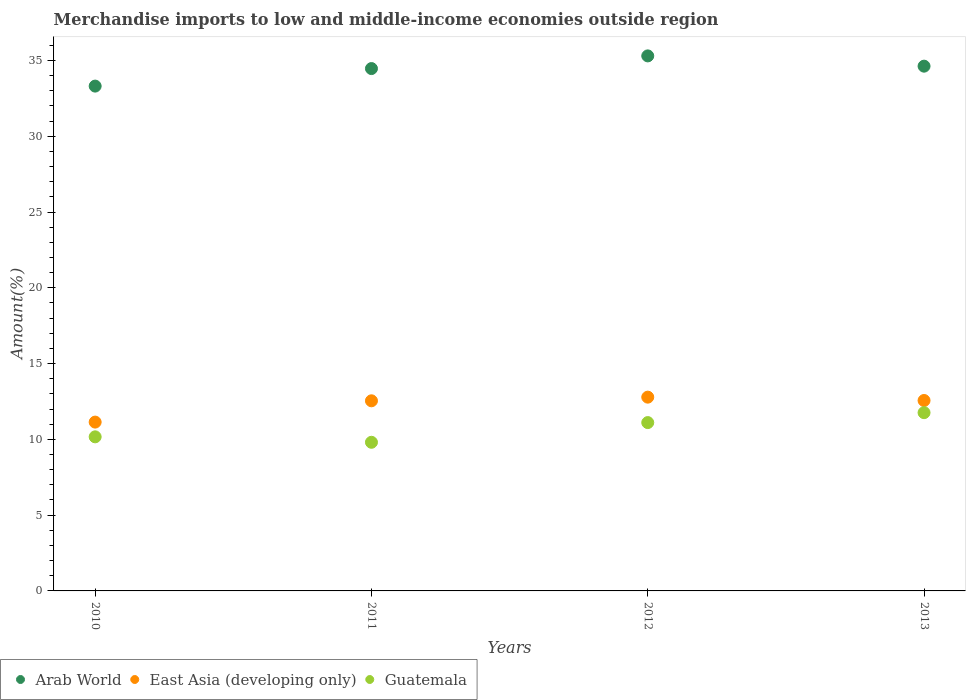Is the number of dotlines equal to the number of legend labels?
Provide a succinct answer. Yes. What is the percentage of amount earned from merchandise imports in Arab World in 2012?
Provide a succinct answer. 35.3. Across all years, what is the maximum percentage of amount earned from merchandise imports in Arab World?
Ensure brevity in your answer.  35.3. Across all years, what is the minimum percentage of amount earned from merchandise imports in Arab World?
Keep it short and to the point. 33.31. What is the total percentage of amount earned from merchandise imports in Arab World in the graph?
Give a very brief answer. 137.7. What is the difference between the percentage of amount earned from merchandise imports in Arab World in 2010 and that in 2013?
Your answer should be compact. -1.32. What is the difference between the percentage of amount earned from merchandise imports in Guatemala in 2011 and the percentage of amount earned from merchandise imports in Arab World in 2012?
Make the answer very short. -25.5. What is the average percentage of amount earned from merchandise imports in Guatemala per year?
Ensure brevity in your answer.  10.71. In the year 2013, what is the difference between the percentage of amount earned from merchandise imports in East Asia (developing only) and percentage of amount earned from merchandise imports in Guatemala?
Give a very brief answer. 0.8. What is the ratio of the percentage of amount earned from merchandise imports in East Asia (developing only) in 2010 to that in 2012?
Your response must be concise. 0.87. Is the difference between the percentage of amount earned from merchandise imports in East Asia (developing only) in 2010 and 2013 greater than the difference between the percentage of amount earned from merchandise imports in Guatemala in 2010 and 2013?
Keep it short and to the point. Yes. What is the difference between the highest and the second highest percentage of amount earned from merchandise imports in Guatemala?
Provide a succinct answer. 0.66. What is the difference between the highest and the lowest percentage of amount earned from merchandise imports in East Asia (developing only)?
Your response must be concise. 1.65. In how many years, is the percentage of amount earned from merchandise imports in Guatemala greater than the average percentage of amount earned from merchandise imports in Guatemala taken over all years?
Make the answer very short. 2. Is the percentage of amount earned from merchandise imports in Arab World strictly greater than the percentage of amount earned from merchandise imports in East Asia (developing only) over the years?
Provide a succinct answer. Yes. Is the percentage of amount earned from merchandise imports in East Asia (developing only) strictly less than the percentage of amount earned from merchandise imports in Guatemala over the years?
Keep it short and to the point. No. How many dotlines are there?
Offer a very short reply. 3. What is the difference between two consecutive major ticks on the Y-axis?
Provide a short and direct response. 5. Are the values on the major ticks of Y-axis written in scientific E-notation?
Provide a succinct answer. No. Where does the legend appear in the graph?
Keep it short and to the point. Bottom left. How are the legend labels stacked?
Ensure brevity in your answer.  Horizontal. What is the title of the graph?
Offer a very short reply. Merchandise imports to low and middle-income economies outside region. What is the label or title of the Y-axis?
Your response must be concise. Amount(%). What is the Amount(%) in Arab World in 2010?
Your answer should be compact. 33.31. What is the Amount(%) of East Asia (developing only) in 2010?
Your answer should be very brief. 11.14. What is the Amount(%) of Guatemala in 2010?
Ensure brevity in your answer.  10.17. What is the Amount(%) of Arab World in 2011?
Ensure brevity in your answer.  34.47. What is the Amount(%) in East Asia (developing only) in 2011?
Offer a terse response. 12.54. What is the Amount(%) of Guatemala in 2011?
Your response must be concise. 9.81. What is the Amount(%) of Arab World in 2012?
Your answer should be very brief. 35.3. What is the Amount(%) in East Asia (developing only) in 2012?
Provide a succinct answer. 12.79. What is the Amount(%) in Guatemala in 2012?
Offer a terse response. 11.11. What is the Amount(%) of Arab World in 2013?
Keep it short and to the point. 34.63. What is the Amount(%) of East Asia (developing only) in 2013?
Offer a terse response. 12.56. What is the Amount(%) of Guatemala in 2013?
Keep it short and to the point. 11.76. Across all years, what is the maximum Amount(%) of Arab World?
Make the answer very short. 35.3. Across all years, what is the maximum Amount(%) in East Asia (developing only)?
Your response must be concise. 12.79. Across all years, what is the maximum Amount(%) of Guatemala?
Ensure brevity in your answer.  11.76. Across all years, what is the minimum Amount(%) of Arab World?
Keep it short and to the point. 33.31. Across all years, what is the minimum Amount(%) in East Asia (developing only)?
Provide a short and direct response. 11.14. Across all years, what is the minimum Amount(%) in Guatemala?
Offer a terse response. 9.81. What is the total Amount(%) of Arab World in the graph?
Your response must be concise. 137.7. What is the total Amount(%) of East Asia (developing only) in the graph?
Your response must be concise. 49.03. What is the total Amount(%) of Guatemala in the graph?
Your answer should be compact. 42.84. What is the difference between the Amount(%) in Arab World in 2010 and that in 2011?
Provide a succinct answer. -1.16. What is the difference between the Amount(%) of East Asia (developing only) in 2010 and that in 2011?
Ensure brevity in your answer.  -1.41. What is the difference between the Amount(%) of Guatemala in 2010 and that in 2011?
Your response must be concise. 0.36. What is the difference between the Amount(%) of Arab World in 2010 and that in 2012?
Make the answer very short. -1.99. What is the difference between the Amount(%) in East Asia (developing only) in 2010 and that in 2012?
Offer a very short reply. -1.65. What is the difference between the Amount(%) in Guatemala in 2010 and that in 2012?
Your answer should be compact. -0.94. What is the difference between the Amount(%) of Arab World in 2010 and that in 2013?
Make the answer very short. -1.32. What is the difference between the Amount(%) in East Asia (developing only) in 2010 and that in 2013?
Your answer should be compact. -1.43. What is the difference between the Amount(%) of Guatemala in 2010 and that in 2013?
Provide a succinct answer. -1.6. What is the difference between the Amount(%) of Arab World in 2011 and that in 2012?
Your answer should be compact. -0.84. What is the difference between the Amount(%) of East Asia (developing only) in 2011 and that in 2012?
Provide a short and direct response. -0.24. What is the difference between the Amount(%) of Guatemala in 2011 and that in 2012?
Offer a terse response. -1.3. What is the difference between the Amount(%) of Arab World in 2011 and that in 2013?
Offer a very short reply. -0.16. What is the difference between the Amount(%) in East Asia (developing only) in 2011 and that in 2013?
Keep it short and to the point. -0.02. What is the difference between the Amount(%) in Guatemala in 2011 and that in 2013?
Keep it short and to the point. -1.95. What is the difference between the Amount(%) in Arab World in 2012 and that in 2013?
Offer a very short reply. 0.68. What is the difference between the Amount(%) of East Asia (developing only) in 2012 and that in 2013?
Make the answer very short. 0.22. What is the difference between the Amount(%) in Guatemala in 2012 and that in 2013?
Your response must be concise. -0.66. What is the difference between the Amount(%) in Arab World in 2010 and the Amount(%) in East Asia (developing only) in 2011?
Your answer should be very brief. 20.76. What is the difference between the Amount(%) in Arab World in 2010 and the Amount(%) in Guatemala in 2011?
Provide a short and direct response. 23.5. What is the difference between the Amount(%) of East Asia (developing only) in 2010 and the Amount(%) of Guatemala in 2011?
Ensure brevity in your answer.  1.33. What is the difference between the Amount(%) of Arab World in 2010 and the Amount(%) of East Asia (developing only) in 2012?
Ensure brevity in your answer.  20.52. What is the difference between the Amount(%) in Arab World in 2010 and the Amount(%) in Guatemala in 2012?
Keep it short and to the point. 22.2. What is the difference between the Amount(%) of East Asia (developing only) in 2010 and the Amount(%) of Guatemala in 2012?
Offer a terse response. 0.03. What is the difference between the Amount(%) in Arab World in 2010 and the Amount(%) in East Asia (developing only) in 2013?
Offer a terse response. 20.74. What is the difference between the Amount(%) of Arab World in 2010 and the Amount(%) of Guatemala in 2013?
Make the answer very short. 21.55. What is the difference between the Amount(%) of East Asia (developing only) in 2010 and the Amount(%) of Guatemala in 2013?
Your answer should be very brief. -0.62. What is the difference between the Amount(%) of Arab World in 2011 and the Amount(%) of East Asia (developing only) in 2012?
Your answer should be compact. 21.68. What is the difference between the Amount(%) in Arab World in 2011 and the Amount(%) in Guatemala in 2012?
Your answer should be compact. 23.36. What is the difference between the Amount(%) in East Asia (developing only) in 2011 and the Amount(%) in Guatemala in 2012?
Your response must be concise. 1.44. What is the difference between the Amount(%) of Arab World in 2011 and the Amount(%) of East Asia (developing only) in 2013?
Offer a terse response. 21.9. What is the difference between the Amount(%) in Arab World in 2011 and the Amount(%) in Guatemala in 2013?
Your response must be concise. 22.7. What is the difference between the Amount(%) in East Asia (developing only) in 2011 and the Amount(%) in Guatemala in 2013?
Make the answer very short. 0.78. What is the difference between the Amount(%) in Arab World in 2012 and the Amount(%) in East Asia (developing only) in 2013?
Provide a short and direct response. 22.74. What is the difference between the Amount(%) of Arab World in 2012 and the Amount(%) of Guatemala in 2013?
Offer a very short reply. 23.54. What is the difference between the Amount(%) of East Asia (developing only) in 2012 and the Amount(%) of Guatemala in 2013?
Make the answer very short. 1.02. What is the average Amount(%) in Arab World per year?
Ensure brevity in your answer.  34.43. What is the average Amount(%) of East Asia (developing only) per year?
Give a very brief answer. 12.26. What is the average Amount(%) of Guatemala per year?
Provide a succinct answer. 10.71. In the year 2010, what is the difference between the Amount(%) of Arab World and Amount(%) of East Asia (developing only)?
Ensure brevity in your answer.  22.17. In the year 2010, what is the difference between the Amount(%) in Arab World and Amount(%) in Guatemala?
Provide a short and direct response. 23.14. In the year 2010, what is the difference between the Amount(%) of East Asia (developing only) and Amount(%) of Guatemala?
Make the answer very short. 0.97. In the year 2011, what is the difference between the Amount(%) in Arab World and Amount(%) in East Asia (developing only)?
Your answer should be compact. 21.92. In the year 2011, what is the difference between the Amount(%) in Arab World and Amount(%) in Guatemala?
Your response must be concise. 24.66. In the year 2011, what is the difference between the Amount(%) in East Asia (developing only) and Amount(%) in Guatemala?
Provide a short and direct response. 2.74. In the year 2012, what is the difference between the Amount(%) of Arab World and Amount(%) of East Asia (developing only)?
Your answer should be very brief. 22.52. In the year 2012, what is the difference between the Amount(%) in Arab World and Amount(%) in Guatemala?
Provide a succinct answer. 24.2. In the year 2012, what is the difference between the Amount(%) of East Asia (developing only) and Amount(%) of Guatemala?
Offer a very short reply. 1.68. In the year 2013, what is the difference between the Amount(%) of Arab World and Amount(%) of East Asia (developing only)?
Offer a very short reply. 22.06. In the year 2013, what is the difference between the Amount(%) in Arab World and Amount(%) in Guatemala?
Provide a short and direct response. 22.86. In the year 2013, what is the difference between the Amount(%) in East Asia (developing only) and Amount(%) in Guatemala?
Give a very brief answer. 0.8. What is the ratio of the Amount(%) in Arab World in 2010 to that in 2011?
Your answer should be compact. 0.97. What is the ratio of the Amount(%) of East Asia (developing only) in 2010 to that in 2011?
Your response must be concise. 0.89. What is the ratio of the Amount(%) of Guatemala in 2010 to that in 2011?
Make the answer very short. 1.04. What is the ratio of the Amount(%) in Arab World in 2010 to that in 2012?
Give a very brief answer. 0.94. What is the ratio of the Amount(%) of East Asia (developing only) in 2010 to that in 2012?
Offer a very short reply. 0.87. What is the ratio of the Amount(%) in Guatemala in 2010 to that in 2012?
Your response must be concise. 0.92. What is the ratio of the Amount(%) in East Asia (developing only) in 2010 to that in 2013?
Keep it short and to the point. 0.89. What is the ratio of the Amount(%) in Guatemala in 2010 to that in 2013?
Ensure brevity in your answer.  0.86. What is the ratio of the Amount(%) of Arab World in 2011 to that in 2012?
Give a very brief answer. 0.98. What is the ratio of the Amount(%) of East Asia (developing only) in 2011 to that in 2012?
Provide a succinct answer. 0.98. What is the ratio of the Amount(%) in Guatemala in 2011 to that in 2012?
Your answer should be compact. 0.88. What is the ratio of the Amount(%) in Guatemala in 2011 to that in 2013?
Make the answer very short. 0.83. What is the ratio of the Amount(%) of Arab World in 2012 to that in 2013?
Keep it short and to the point. 1.02. What is the ratio of the Amount(%) in East Asia (developing only) in 2012 to that in 2013?
Provide a short and direct response. 1.02. What is the ratio of the Amount(%) in Guatemala in 2012 to that in 2013?
Offer a terse response. 0.94. What is the difference between the highest and the second highest Amount(%) of Arab World?
Keep it short and to the point. 0.68. What is the difference between the highest and the second highest Amount(%) of East Asia (developing only)?
Keep it short and to the point. 0.22. What is the difference between the highest and the second highest Amount(%) in Guatemala?
Offer a very short reply. 0.66. What is the difference between the highest and the lowest Amount(%) in Arab World?
Make the answer very short. 1.99. What is the difference between the highest and the lowest Amount(%) of East Asia (developing only)?
Provide a succinct answer. 1.65. What is the difference between the highest and the lowest Amount(%) of Guatemala?
Provide a short and direct response. 1.95. 